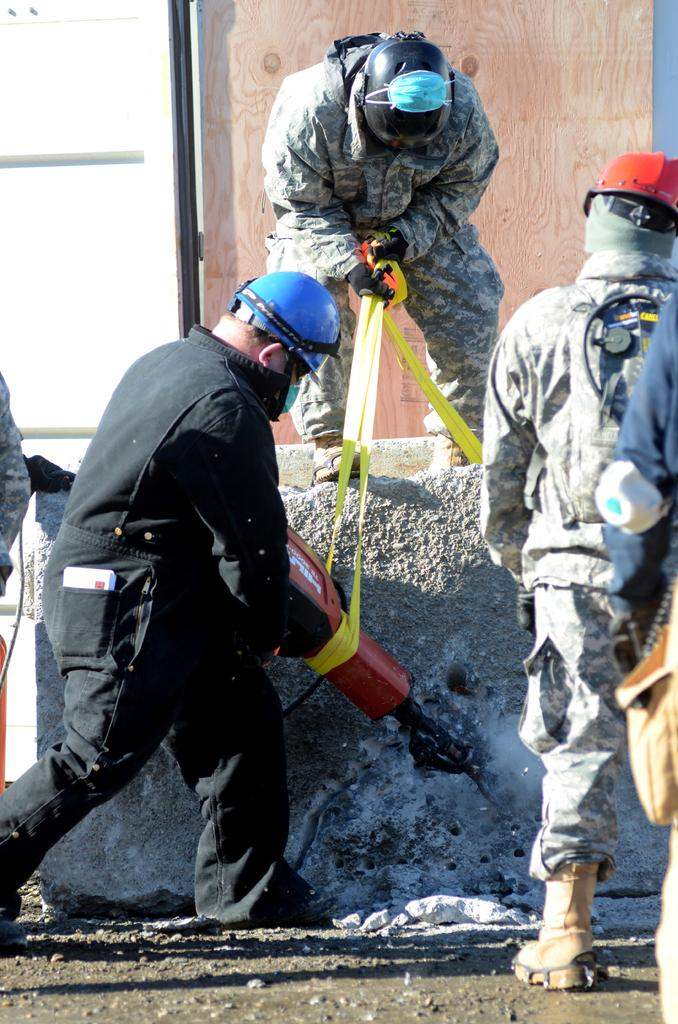What is the person in the image holding? The person is holding a machine. How many people are wearing uniforms in the image? There are 2 people present wearing a uniform. Can you describe the location of the door in the image? There is a door at the back. What type of street is visible in the image? There is no street visible in the image. Is there a tent present in the image? There is no tent present in the image. 